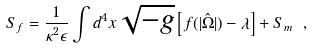<formula> <loc_0><loc_0><loc_500><loc_500>S _ { f } = \frac { 1 } { \kappa ^ { 2 } \epsilon } \int d ^ { 4 } x \sqrt { - g } \left [ f ( | \hat { \Omega } | ) - \lambda \right ] + S _ { m } \ ,</formula> 